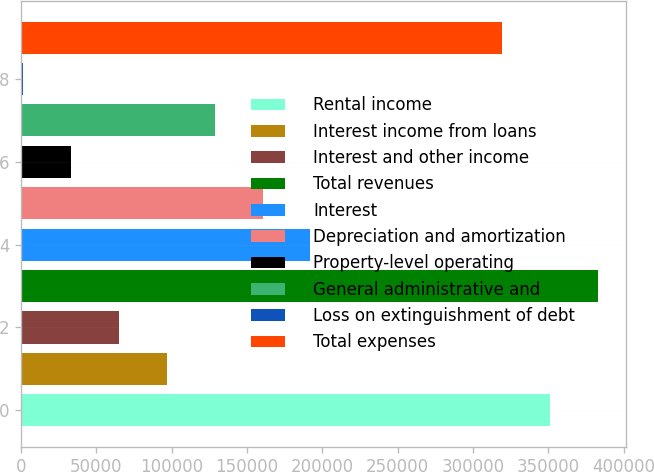Convert chart. <chart><loc_0><loc_0><loc_500><loc_500><bar_chart><fcel>Rental income<fcel>Interest income from loans<fcel>Interest and other income<fcel>Total revenues<fcel>Interest<fcel>Depreciation and amortization<fcel>Property-level operating<fcel>General administrative and<fcel>Loss on extinguishment of debt<fcel>Total expenses<nl><fcel>350965<fcel>96718.4<fcel>64937.6<fcel>382746<fcel>192061<fcel>160280<fcel>33156.8<fcel>128499<fcel>1376<fcel>319184<nl></chart> 